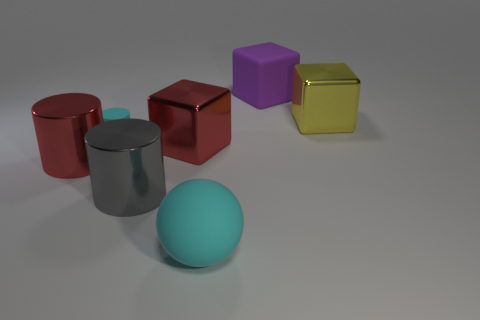Is the color of the large rubber block the same as the big matte object that is in front of the tiny cyan rubber cylinder?
Your answer should be very brief. No. How many cylinders are in front of the gray cylinder?
Offer a very short reply. 0. Are there fewer tiny yellow spheres than objects?
Provide a succinct answer. Yes. What is the size of the rubber thing that is behind the big rubber ball and right of the small cyan rubber thing?
Your answer should be compact. Large. There is a large cylinder right of the small rubber object; is its color the same as the tiny thing?
Provide a succinct answer. No. Are there fewer gray metallic cylinders that are behind the big cyan rubber ball than small blue matte cylinders?
Provide a succinct answer. No. There is a large gray object that is made of the same material as the large red cylinder; what is its shape?
Provide a succinct answer. Cylinder. Is the cyan ball made of the same material as the yellow cube?
Give a very brief answer. No. Are there fewer shiny cubes that are in front of the matte cylinder than large things that are behind the large ball?
Your answer should be compact. Yes. What is the size of the sphere that is the same color as the tiny cylinder?
Offer a very short reply. Large. 